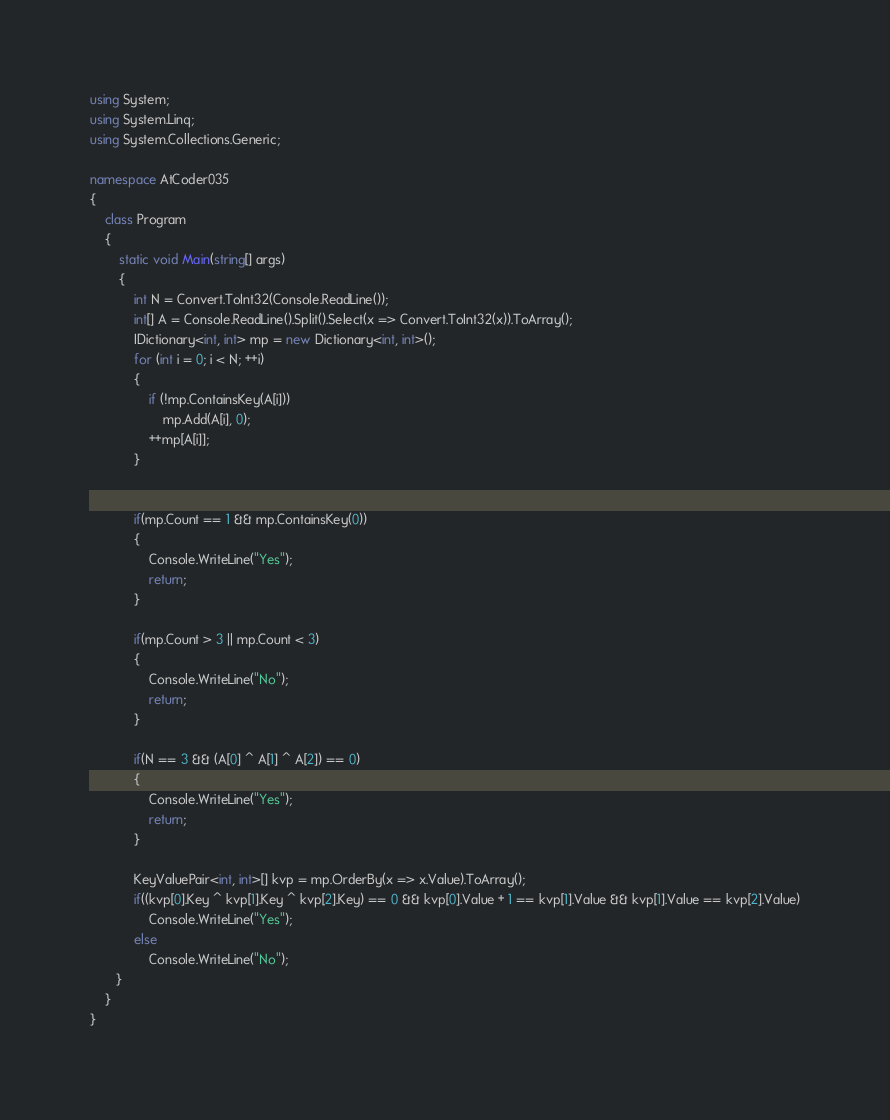Convert code to text. <code><loc_0><loc_0><loc_500><loc_500><_C#_>using System;
using System.Linq;
using System.Collections.Generic;

namespace AtCoder035
{
    class Program
    {
        static void Main(string[] args)
        {
            int N = Convert.ToInt32(Console.ReadLine());
            int[] A = Console.ReadLine().Split().Select(x => Convert.ToInt32(x)).ToArray();
            IDictionary<int, int> mp = new Dictionary<int, int>();
            for (int i = 0; i < N; ++i)
            {
                if (!mp.ContainsKey(A[i]))
                    mp.Add(A[i], 0);
                ++mp[A[i]];
            }


            if(mp.Count == 1 && mp.ContainsKey(0))
            {
                Console.WriteLine("Yes");
                return;
            }

            if(mp.Count > 3 || mp.Count < 3)
            {
                Console.WriteLine("No");
                return;
            }

            if(N == 3 && (A[0] ^ A[1] ^ A[2]) == 0)
            {
                Console.WriteLine("Yes");
                return;
            }

            KeyValuePair<int, int>[] kvp = mp.OrderBy(x => x.Value).ToArray();
            if((kvp[0].Key ^ kvp[1].Key ^ kvp[2].Key) == 0 && kvp[0].Value + 1 == kvp[1].Value && kvp[1].Value == kvp[2].Value)
                Console.WriteLine("Yes");
            else
                Console.WriteLine("No");
       }
    }
}</code> 